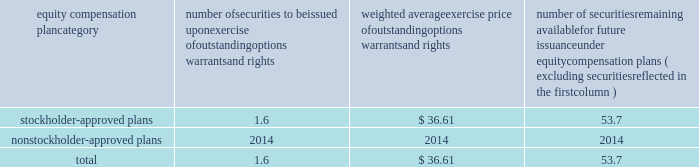Bhge 2017 form 10-k | 103 part iii item 10 .
Directors , executive officers and corporate governance information regarding our code of conduct , the spirit and the letter , and code of ethical conduct certificates for our principal executive officer , principal financial officer and principal accounting officer are described in item 1 .
Business of this annual report .
Information concerning our directors is set forth in the sections entitled "proposal no .
1 , election of directors - board nominees for directors" and "corporate governance - committees of the board" in our definitive proxy statement for the 2018 annual meeting of stockholders to be filed with the sec pursuant to the exchange act within 120 days of the end of our fiscal year on december 31 , 2017 ( "proxy statement" ) , which sections are incorporated herein by reference .
For information regarding our executive officers , see "item 1 .
Business - executive officers of baker hughes" in this annual report on form 10-k .
Additional information regarding compliance by directors and executive officers with section 16 ( a ) of the exchange act is set forth under the section entitled "section 16 ( a ) beneficial ownership reporting compliance" in our proxy statement , which section is incorporated herein by reference .
Item 11 .
Executive compensation information for this item is set forth in the following sections of our proxy statement , which sections are incorporated herein by reference : "compensation discussion and analysis" "director compensation" "compensation committee interlocks and insider participation" and "compensation committee report." item 12 .
Security ownership of certain beneficial owners and management and related stockholder matters information concerning security ownership of certain beneficial owners and our management is set forth in the sections entitled "stock ownership of certain beneficial owners" and 201cstock ownership of section 16 ( a ) director and executive officers 201d ) in our proxy statement , which sections are incorporated herein by reference .
We permit our employees , officers and directors to enter into written trading plans complying with rule 10b5-1 under the exchange act .
Rule 10b5-1 provides criteria under which such an individual may establish a prearranged plan to buy or sell a specified number of shares of a company's stock over a set period of time .
Any such plan must be entered into in good faith at a time when the individual is not in possession of material , nonpublic information .
If an individual establishes a plan satisfying the requirements of rule 10b5-1 , such individual's subsequent receipt of material , nonpublic information will not prevent transactions under the plan from being executed .
Certain of our officers have advised us that they have and may enter into stock sales plans for the sale of shares of our class a common stock which are intended to comply with the requirements of rule 10b5-1 of the exchange act .
In addition , the company has and may in the future enter into repurchases of our class a common stock under a plan that complies with rule 10b5-1 or rule 10b-18 of the exchange act .
Equity compensation plan information the information in the table is presented as of december 31 , 2017 with respect to shares of our class a common stock that may be issued under our lti plan which has been approved by our stockholders ( in millions , except per share prices ) .
Equity compensation plan category number of securities to be issued upon exercise of outstanding options , warrants and rights weighted average exercise price of outstanding options , warrants and rights number of securities remaining available for future issuance under equity compensation plans ( excluding securities reflected in the first column ) .

What portion of the approved securities is to be issued upon exercise of outstanding options warrants rights? 
Computations: (1.6 / (1.6 + 53.7))
Answer: 0.02893. 